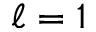<formula> <loc_0><loc_0><loc_500><loc_500>\ell = 1</formula> 